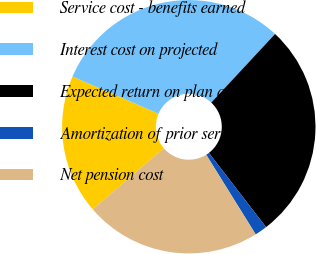<chart> <loc_0><loc_0><loc_500><loc_500><pie_chart><fcel>Service cost - benefits earned<fcel>Interest cost on projected<fcel>Expected return on plan assets<fcel>Amortization of prior service<fcel>Net pension cost<nl><fcel>17.79%<fcel>30.43%<fcel>27.64%<fcel>1.59%<fcel>22.55%<nl></chart> 